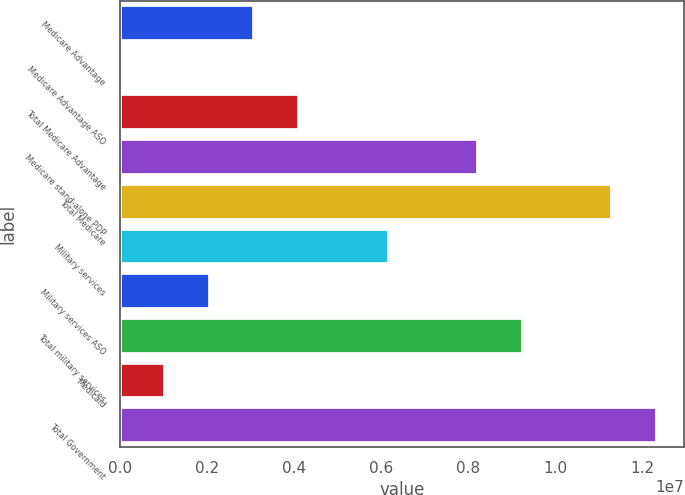Convert chart to OTSL. <chart><loc_0><loc_0><loc_500><loc_500><bar_chart><fcel>Medicare Advantage<fcel>Medicare Advantage ASO<fcel>Total Medicare Advantage<fcel>Medicare stand-alone PDP<fcel>Total Medicare<fcel>Military services<fcel>Military services ASO<fcel>Total military services<fcel>Medicaid<fcel>Total Government<nl><fcel>3.08499e+06<fcel>1.84<fcel>4.11332e+06<fcel>8.22664e+06<fcel>1.13116e+07<fcel>6.16998e+06<fcel>2.05666e+06<fcel>9.25497e+06<fcel>1.02833e+06<fcel>1.234e+07<nl></chart> 